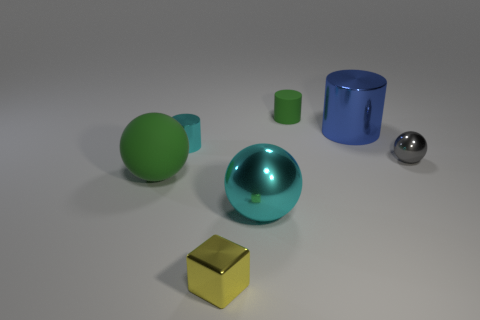Add 2 tiny gray metal things. How many objects exist? 9 Subtract all balls. How many objects are left? 4 Subtract 0 red balls. How many objects are left? 7 Subtract all tiny brown cylinders. Subtract all metal cylinders. How many objects are left? 5 Add 1 big green rubber things. How many big green rubber things are left? 2 Add 2 yellow matte balls. How many yellow matte balls exist? 2 